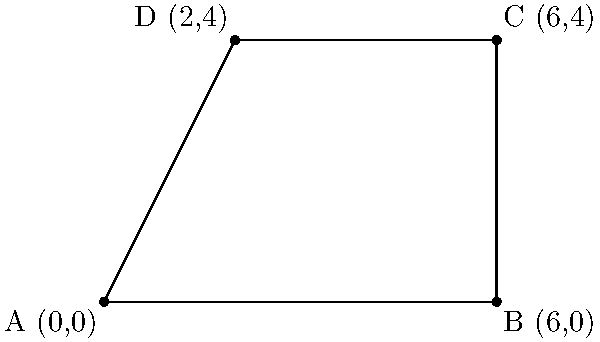As part of a community service project, you are tasked with calculating the area of a neighborhood cleanup zone. The zone is represented by a quadrilateral ABCD on a coordinate plane, where A(0,0), B(6,0), C(6,4), and D(2,4) are the vertices. Calculate the area of this cleanup zone using coordinate geometry. To calculate the area of the quadrilateral ABCD, we can split it into two triangles: ABC and ACD. Then, we can use the formula for the area of a triangle using coordinates:

Area of a triangle = $\frac{1}{2}|x_1(y_2 - y_3) + x_2(y_3 - y_1) + x_3(y_1 - y_2)|$

Step 1: Calculate the area of triangle ABC
$A_1 = \frac{1}{2}|0(0 - 4) + 6(4 - 0) + 6(0 - 0)| = \frac{1}{2}|0 + 24 + 0| = 12$

Step 2: Calculate the area of triangle ACD
$A_2 = \frac{1}{2}|0(4 - 4) + 2(4 - 0) + 6(0 - 4)| = \frac{1}{2}|0 + 8 - 24| = 8$

Step 3: Sum the areas of both triangles
Total Area = $A_1 + A_2 = 12 + 8 = 20$

Therefore, the area of the cleanup zone is 20 square units.
Answer: 20 square units 